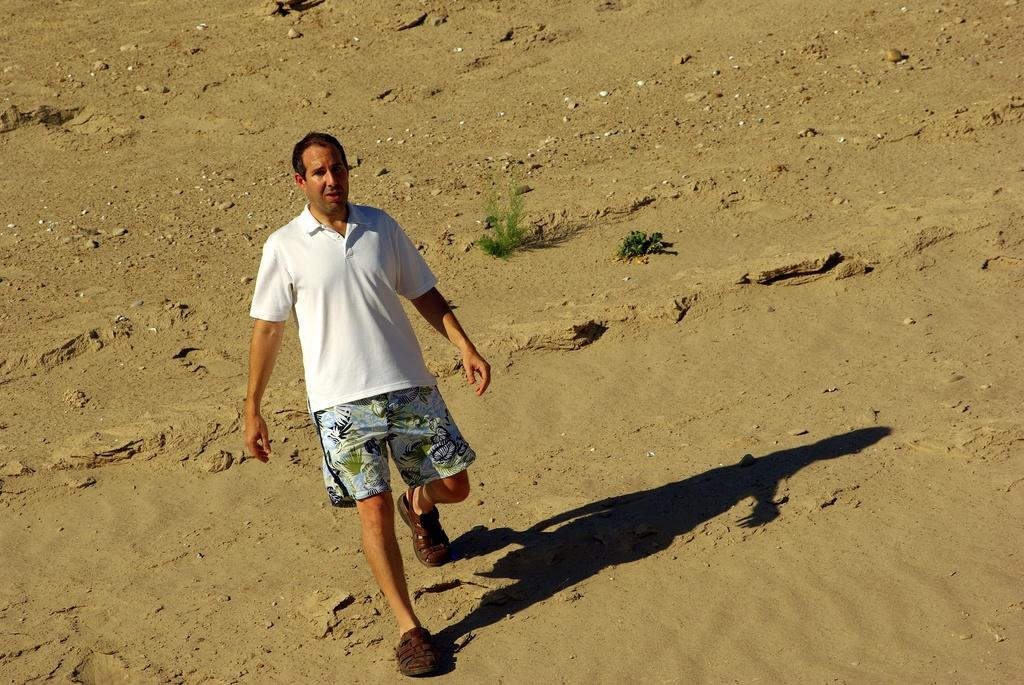What is the main subject in the foreground of the image? There is a man in the foreground of the image. How many oranges is the girl holding in the image? There is no girl or oranges present in the image. 